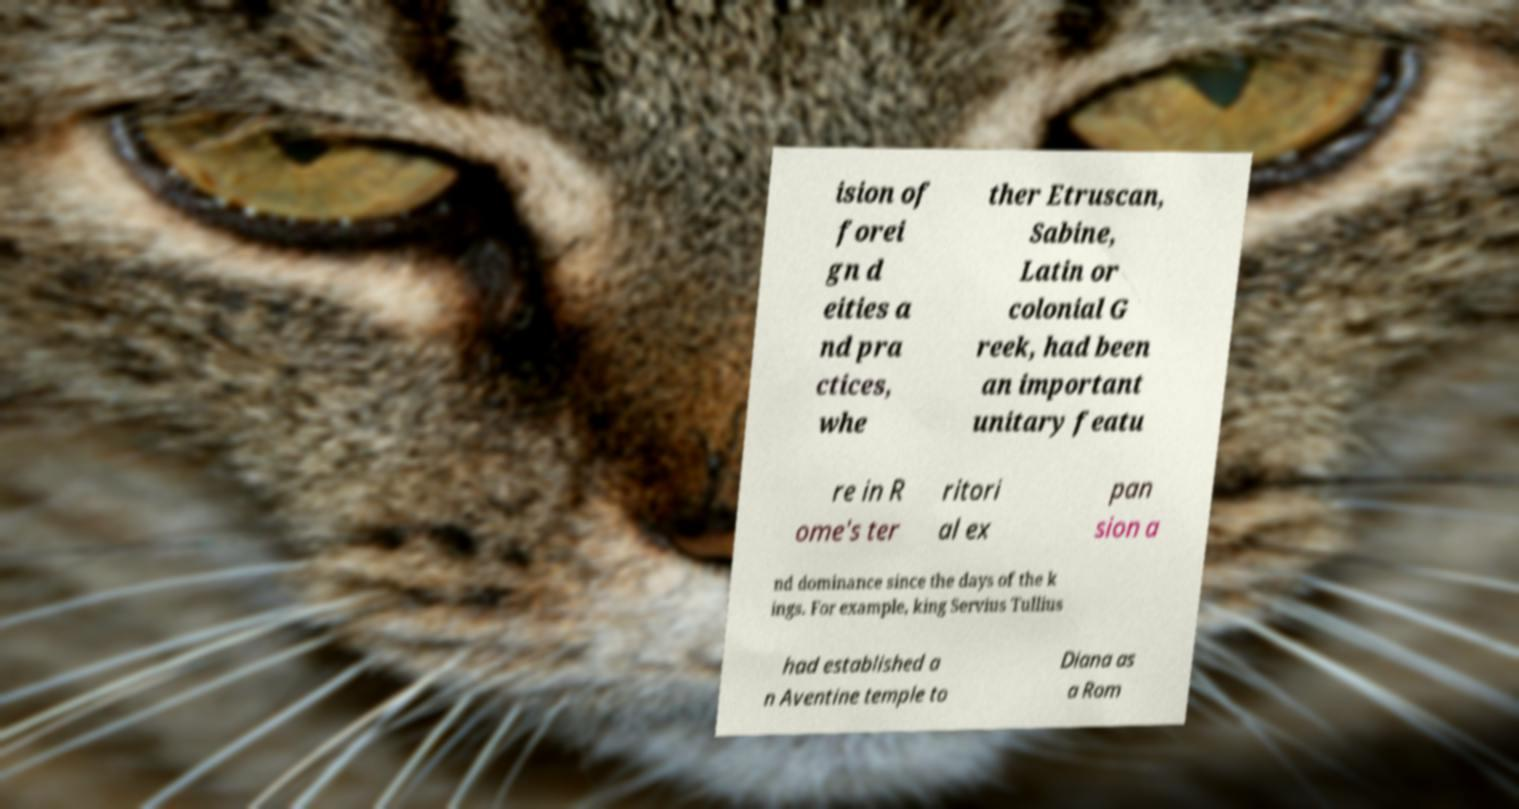There's text embedded in this image that I need extracted. Can you transcribe it verbatim? ision of forei gn d eities a nd pra ctices, whe ther Etruscan, Sabine, Latin or colonial G reek, had been an important unitary featu re in R ome's ter ritori al ex pan sion a nd dominance since the days of the k ings. For example, king Servius Tullius had established a n Aventine temple to Diana as a Rom 